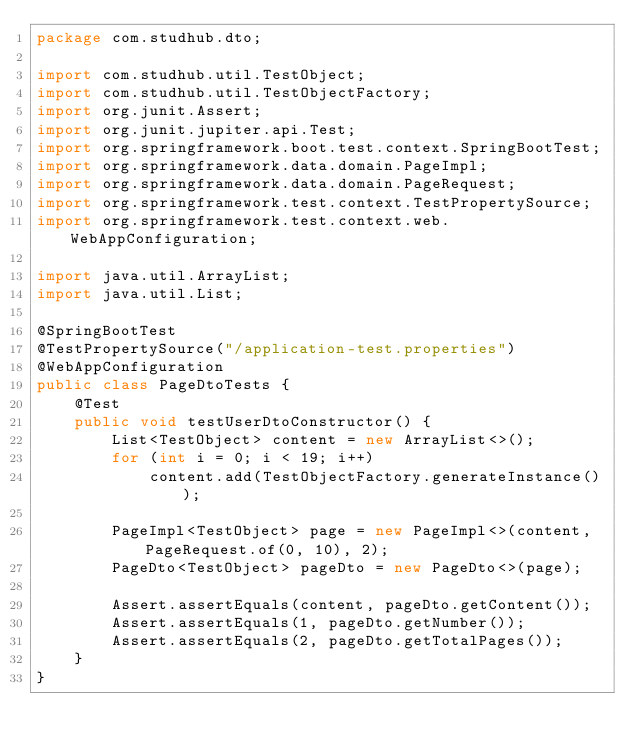<code> <loc_0><loc_0><loc_500><loc_500><_Java_>package com.studhub.dto;

import com.studhub.util.TestObject;
import com.studhub.util.TestObjectFactory;
import org.junit.Assert;
import org.junit.jupiter.api.Test;
import org.springframework.boot.test.context.SpringBootTest;
import org.springframework.data.domain.PageImpl;
import org.springframework.data.domain.PageRequest;
import org.springframework.test.context.TestPropertySource;
import org.springframework.test.context.web.WebAppConfiguration;

import java.util.ArrayList;
import java.util.List;

@SpringBootTest
@TestPropertySource("/application-test.properties")
@WebAppConfiguration
public class PageDtoTests {
    @Test
    public void testUserDtoConstructor() {
        List<TestObject> content = new ArrayList<>();
        for (int i = 0; i < 19; i++)
            content.add(TestObjectFactory.generateInstance());

        PageImpl<TestObject> page = new PageImpl<>(content, PageRequest.of(0, 10), 2);
        PageDto<TestObject> pageDto = new PageDto<>(page);

        Assert.assertEquals(content, pageDto.getContent());
        Assert.assertEquals(1, pageDto.getNumber());
        Assert.assertEquals(2, pageDto.getTotalPages());
    }
}
</code> 